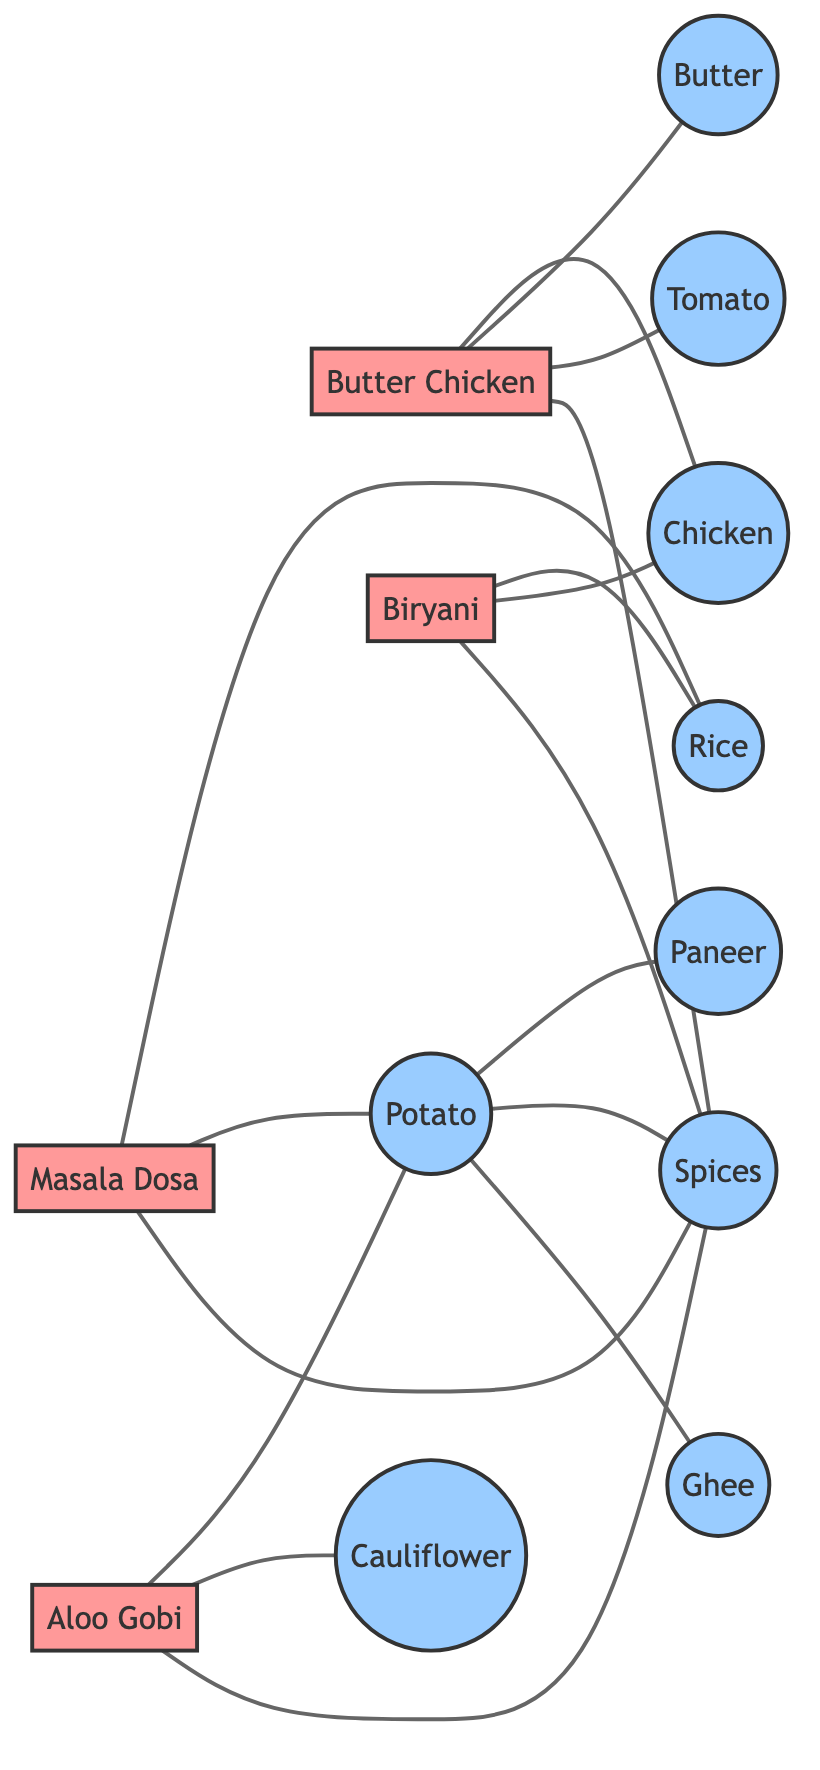What are the primary ingredients used in Butter Chicken? To answer this question, we look for the node "Butter Chicken" and trace the edges leading to the ingredient nodes connected to it. The connected ingredients are Chicken, Butter, Tomato, and Spices.
Answer: Chicken, Butter, Tomato, Spices How many dishes are represented in the diagram? We count the number of nodes that belong to the "dish" group. The nodes are Butter Chicken, Paneer Tikka, Biryani, Masala Dosa, and Aloo Gobi, which totals 5 dishes.
Answer: 5 Which ingredient connects both Biryani and Butter Chicken? We need to find the common ingredients shared between the nodes Biryani and Butter Chicken. Chicken and Spices are the ingredients they both share, but Chicken is the first found connection between them.
Answer: Chicken What is the relationship between Masala Dosa and Potato? By checking the connection from the Masala Dosa node, we see that there is a direct undirected connection (or edge) to the Potato node, indicating that Potato is one of the primary ingredients of Masala Dosa.
Answer: Ingredient How many unique ingredients are listed in the diagram? We find the ingredient nodes by inspecting the category "ingredient". The unique ingredients are Chicken, Paneer, Rice, Potato, Cauliflower, Butter, Tomato, Spices, and Ghee which totals 9 unique ingredients.
Answer: 9 Which dish has Paneer as its primary ingredient? We identify the node "Paneer" and look at the linked dishes. The only dish connected to Paneer is Paneer Tikka, indicating it is the sole dish that lists Paneer as an ingredient.
Answer: Paneer Tikka What is the only connection that Aloo Gobi has with other ingredients? For Aloo Gobi, we check the linked edges and record Cauliflower and Potato as directly connected, alongside Spices, establishing that Aloo Gobi connects with three other ingredients.
Answer: Cauliflower, Potato, Spices Which dish requires Rice as a key ingredient? Reading through the edges, we find that both Biryani and Masala Dosa are linked to Rice, indicating that both dishes require this ingredient for their preparation.
Answer: Biryani, Masala Dosa 